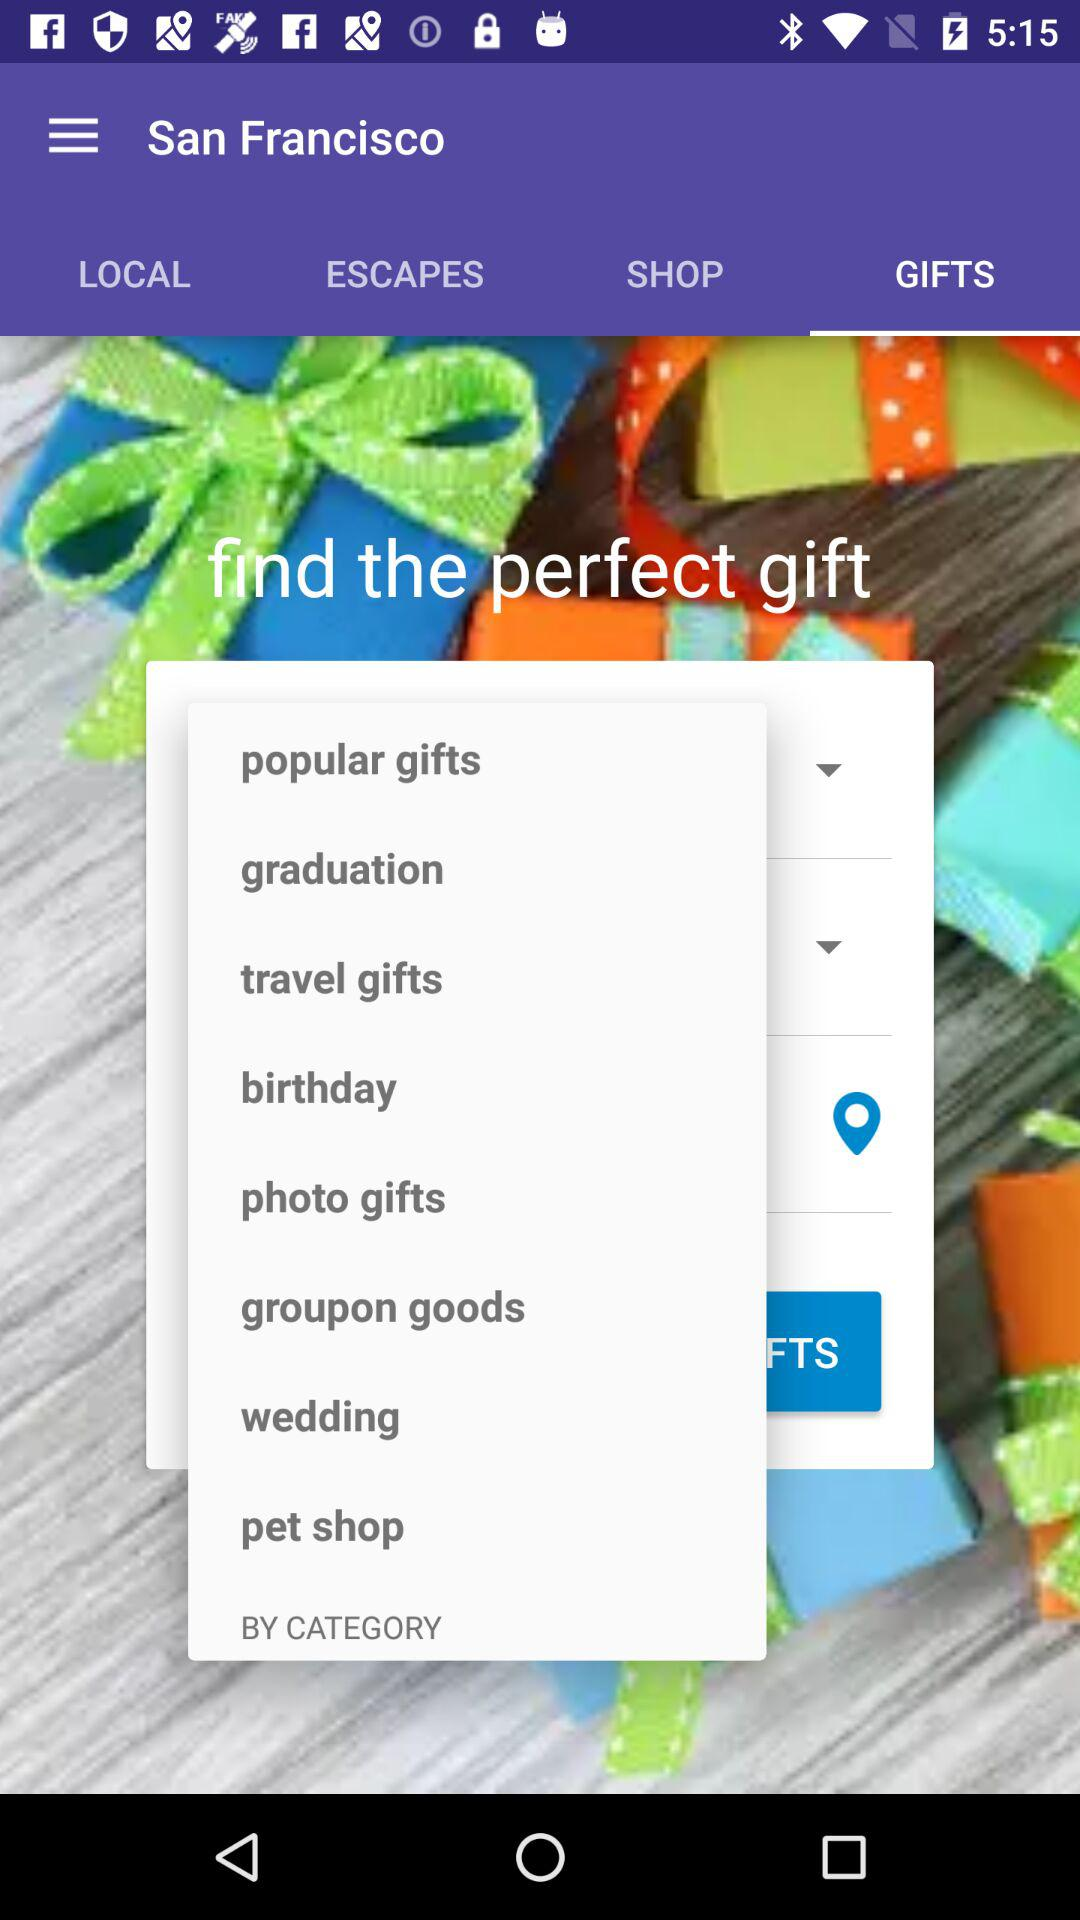Which tab is selected? The selected tab is "GIFTS". 